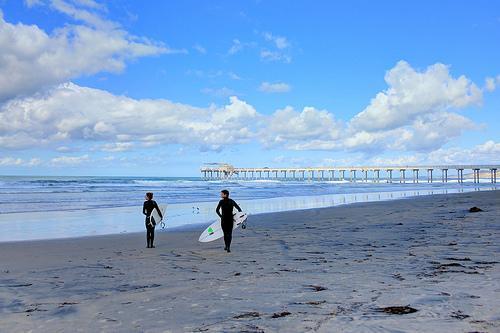How many surfers are there?
Give a very brief answer. 2. 